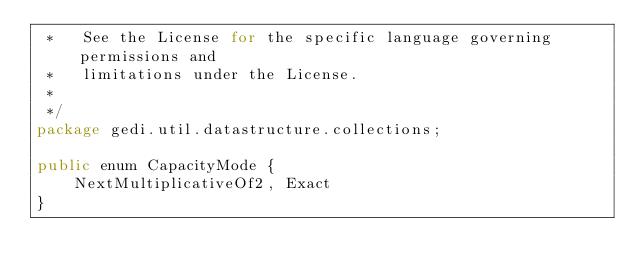Convert code to text. <code><loc_0><loc_0><loc_500><loc_500><_Java_> *   See the License for the specific language governing permissions and
 *   limitations under the License.
 * 
 */
package gedi.util.datastructure.collections;

public enum CapacityMode {
	NextMultiplicativeOf2, Exact
}
</code> 